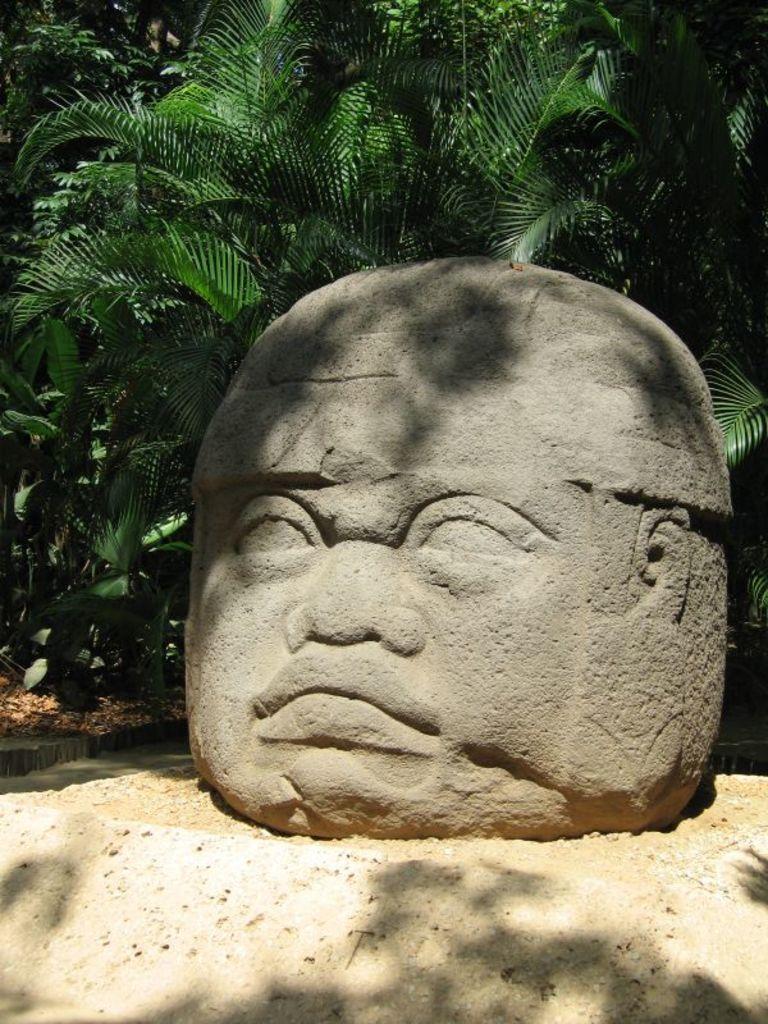In one or two sentences, can you explain what this image depicts? In this image we can see a person face figure on a rock on the ground. In the background there are plants and trees. 